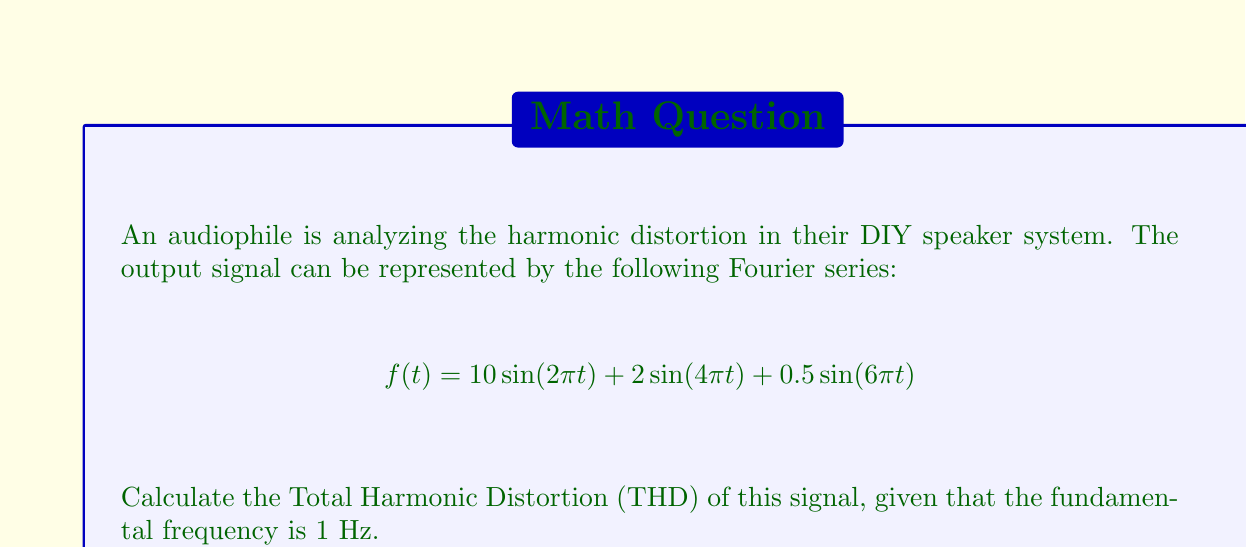Give your solution to this math problem. To calculate the Total Harmonic Distortion (THD), we need to follow these steps:

1) Identify the fundamental frequency and harmonics:
   - Fundamental (1st harmonic): $10\sin(2\pi t)$
   - 2nd harmonic: $2\sin(4\pi t)$
   - 3rd harmonic: $0.5\sin(6\pi t)$

2) Calculate the RMS (Root Mean Square) amplitude of each harmonic:
   - For a sine wave, RMS = Amplitude / $\sqrt{2}$
   - Fundamental: $A_1 = 10 / \sqrt{2} = 7.071$
   - 2nd harmonic: $A_2 = 2 / \sqrt{2} = 1.414$
   - 3rd harmonic: $A_3 = 0.5 / \sqrt{2} = 0.354$

3) Calculate the sum of the squares of the harmonic amplitudes:
   $$\sum_{n=2}^{\infty} A_n^2 = A_2^2 + A_3^2 = 1.414^2 + 0.354^2 = 2.125$$

4) Calculate the THD using the formula:
   $$THD = \frac{\sqrt{\sum_{n=2}^{\infty} A_n^2}}{A_1} \times 100\%$$

   $$THD = \frac{\sqrt{2.125}}{7.071} \times 100\% = 20.62\%$$
Answer: 20.62% 